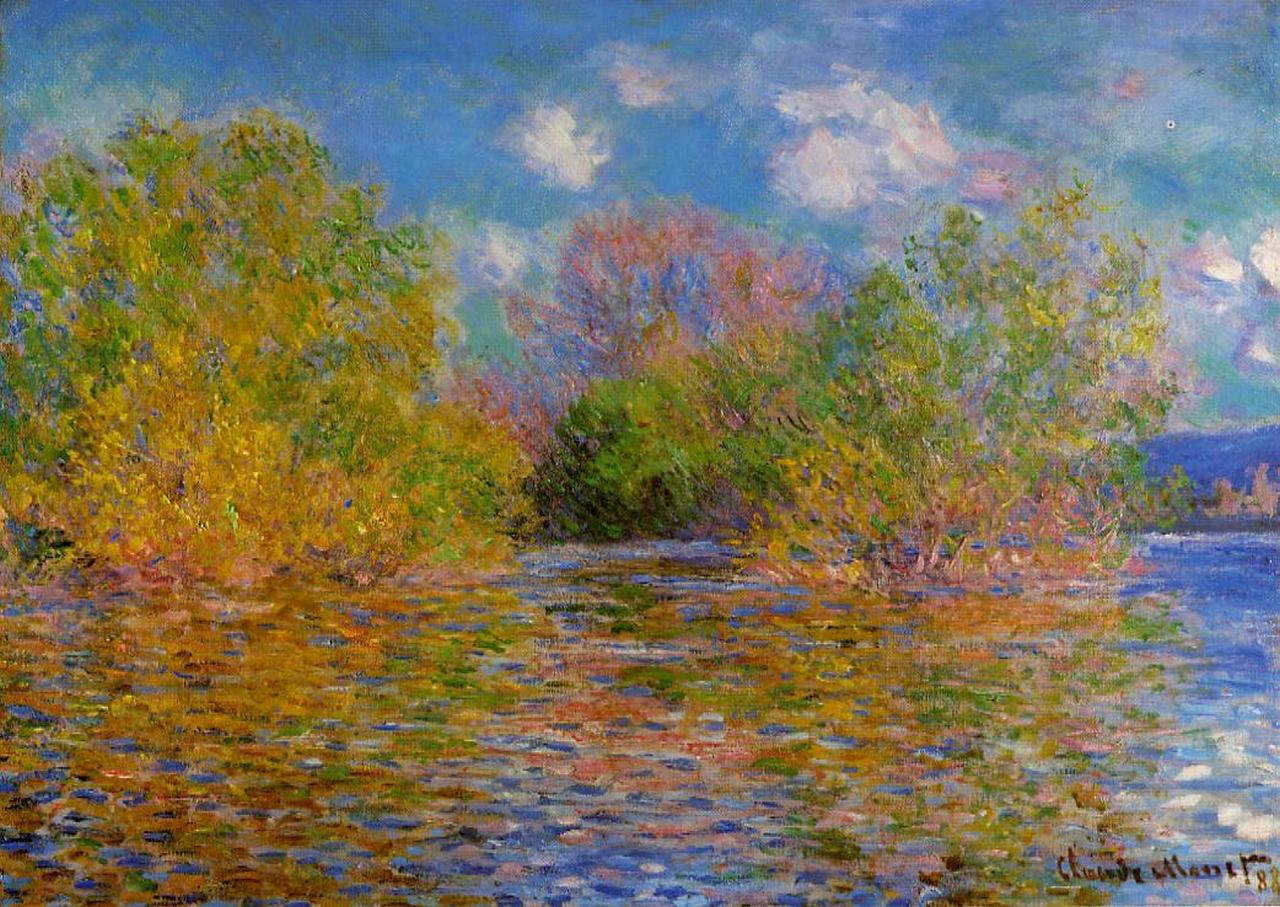Can you describe the impact of light and shadow in this painting? The impact of light and shadow in this painting is profound and masterfully handled. Monet uses dappled light to create a play of brightness and shadow across the canvas. The sunlight filters through the tree leaves, casting delicate patterns on the water and creating a shimmering effect that enhances the sense of movement and life. The shadows are soft and diffuse, adding depth without harshness, and the light seems to be in a constant state of flux, which is a hallmark of Impressionist techniques. How does this painting compare to other works by Monet? This painting shares many characteristics common in Monet's works, such as the focus on natural landscapes, the use of color to convey light and atmosphere, and his distinctive brushwork. Compared to his series paintings like the Water Lilies or Haystacks, this work is more spontaneous, capturing a single moment in time rather than exploring variations over different times of day or seasons. Nevertheless, it showcases his signature approach to capturing the fleeting qualities of natural light and the tranquil beauty of nature. Imagine this scene as part of a narrative or story. What would the plot be? In the heart of Argenteuil, a small village along the Seine, two young lovers meet by the riverbank every day at sunset. They share stories, dreams, and secret promises under the rustling leaves and the golden hues of the closing day. One fateful day, a mysterious letter is found floating on the serene water, revealing a long-lost treasure hidden somewhere within the lush landscape. The discovery sets them on a thrilling adventure, intertwined with the quiet beauty of their rendezvous spot and the ever-changing tapestry of seasons. The river, their silent witness, becomes a central character in their tale of love, mystery, and discovery. 